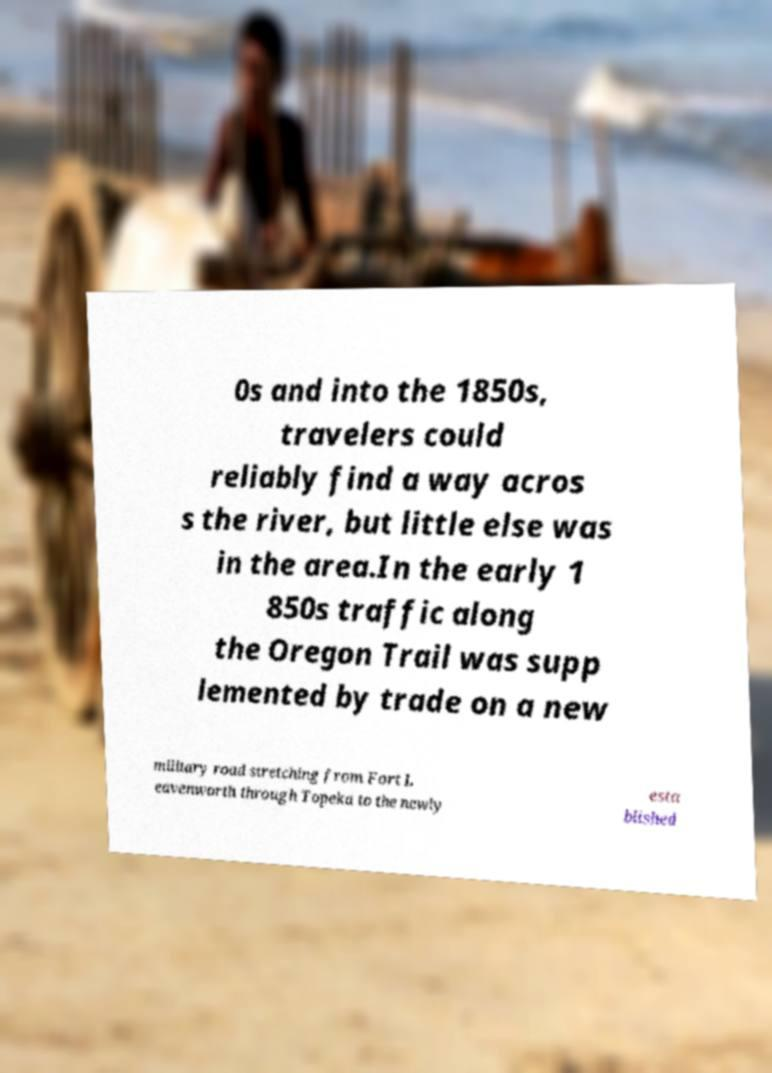Could you assist in decoding the text presented in this image and type it out clearly? 0s and into the 1850s, travelers could reliably find a way acros s the river, but little else was in the area.In the early 1 850s traffic along the Oregon Trail was supp lemented by trade on a new military road stretching from Fort L eavenworth through Topeka to the newly esta blished 